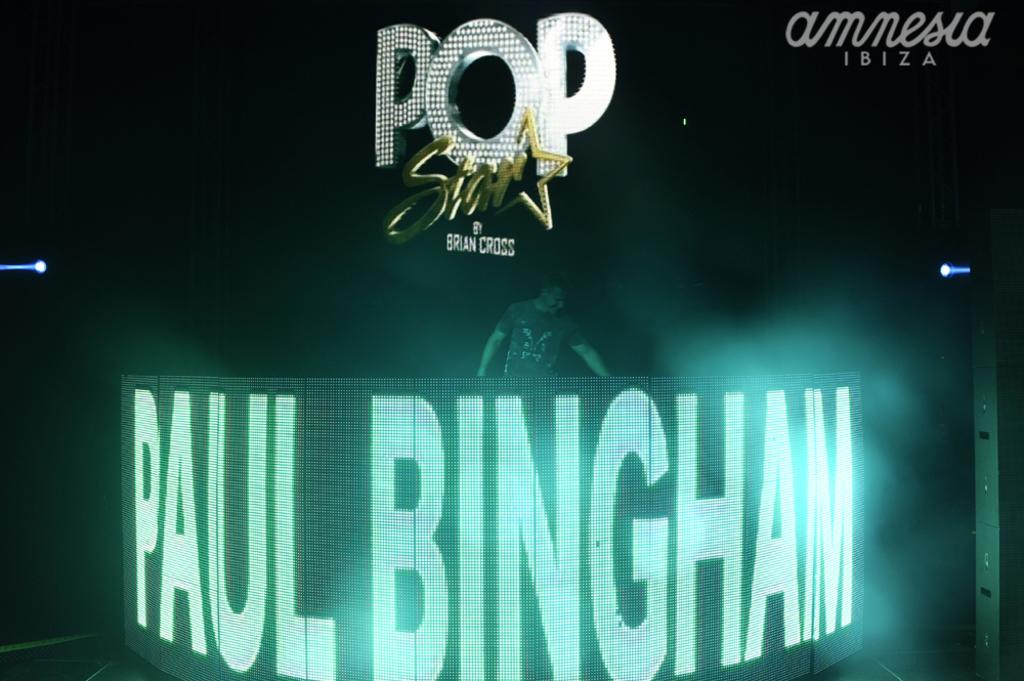What is the main subject of the image? There is a person standing in the image. What is in front of the person? There is an LCD screen in front of the person. What can be seen on the LCD screen? There is text or content visible on the LCD screen. What can be seen in the background of the image? There are boards visible in the background of the image. How would you describe the lighting in the image? The background of the image appears to be dark. Is there any snow visible in the image? No, there is no snow present in the image. Can you see the person's grandmother in the image? There is no mention of a grandmother in the image, so it cannot be determined if she is present. 